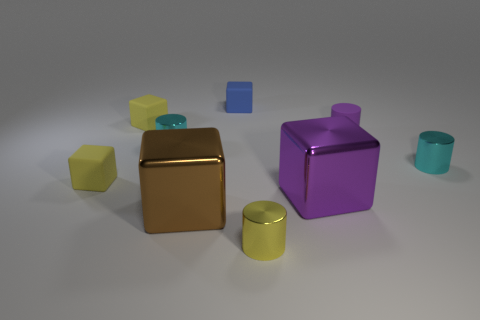There is a purple object that is the same size as the yellow cylinder; what is its shape? cylinder 